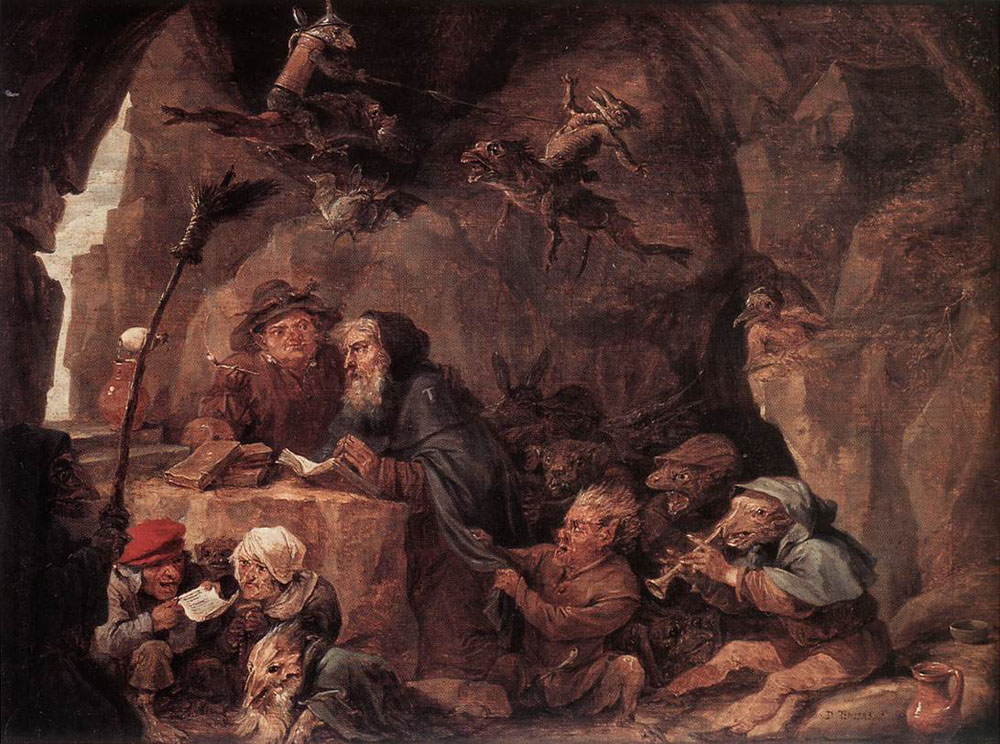What does the setting in the cave tell us about the painting's atmosphere or theme? The cave setting significantly enhances the thematic depth of the painting. It creates a sense of isolation, a hidden world away from the typical human experience. The rugged textures and shadowy corners of the cave help build a mysterious, almost magical atmosphere. This not only frames the dwarves' actions in a realm of fantasy but may also symbolize their separation from mainstream society, underlining themes of solitude, sanctuary, and perhaps, secrecy. 